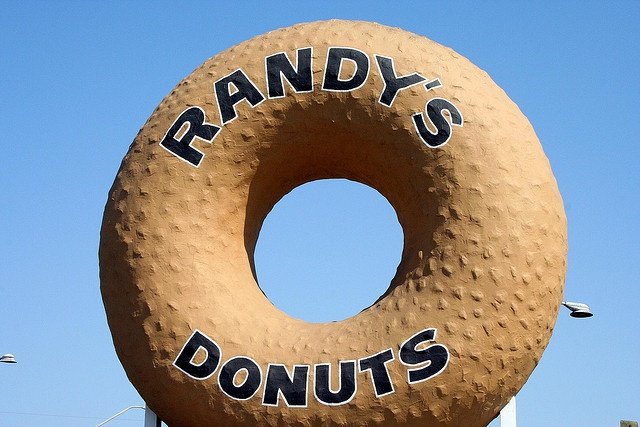Describe the objects in this image and their specific colors. I can see a donut in gray, tan, black, and maroon tones in this image. 